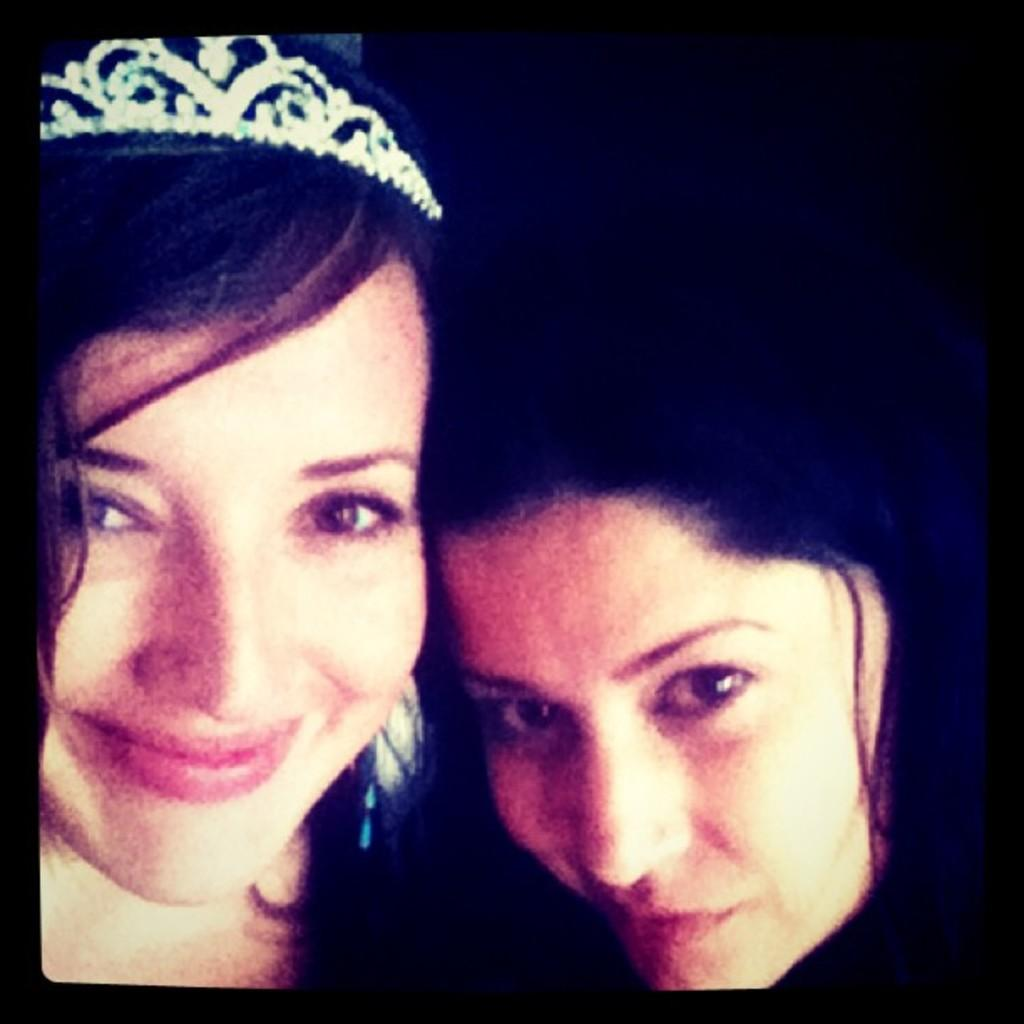How many people are in the image? There are two girls in the image. What can be seen in the background of the image? The background of the image is dark. What type of insect is crawling on the mask near the coast in the image? There is no insect, mask, or coast present in the image; it only features two girls. 